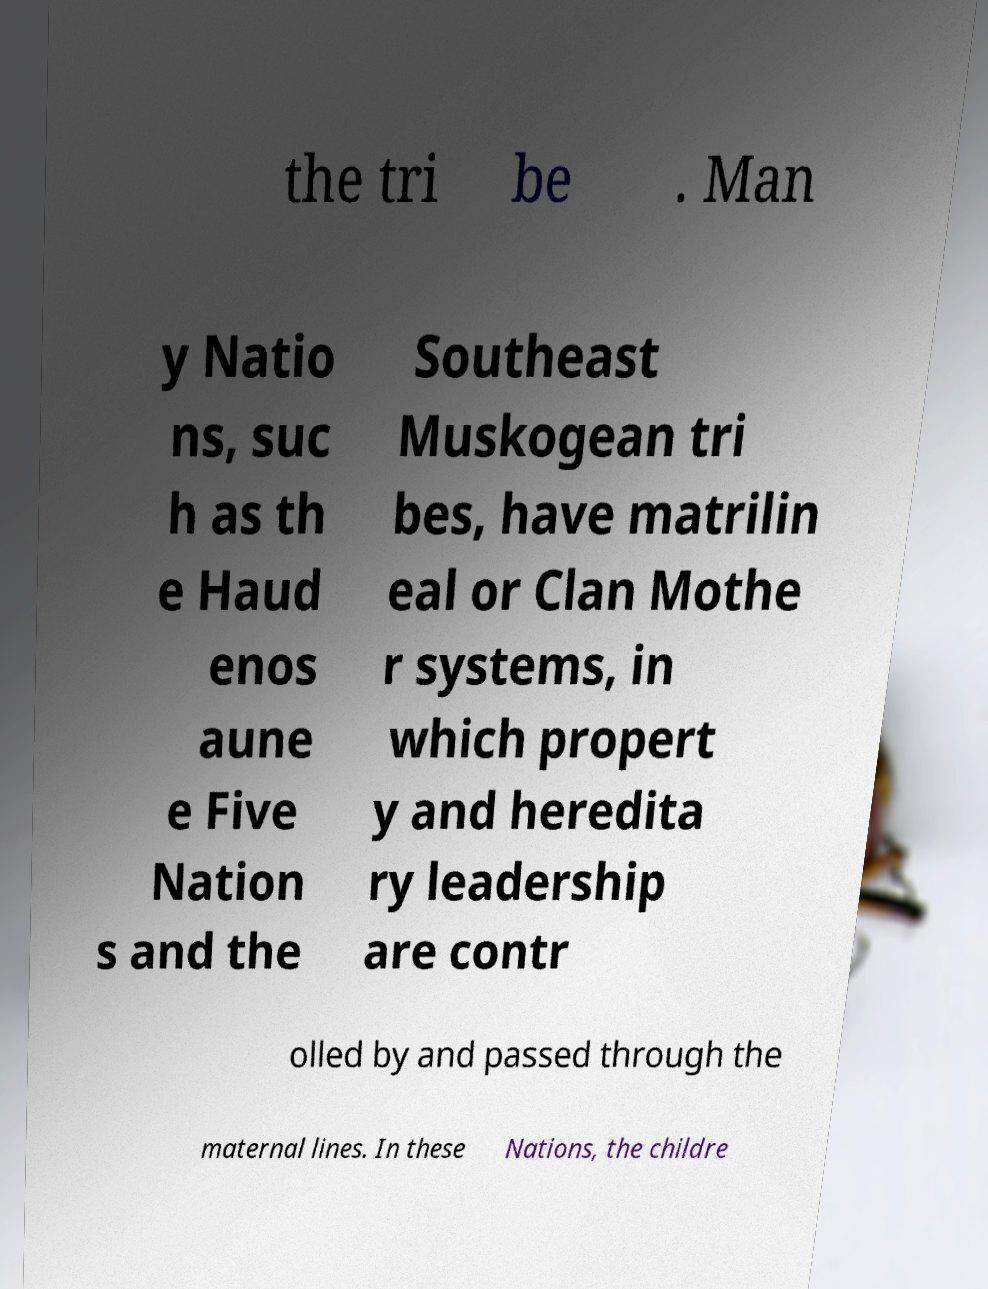Can you accurately transcribe the text from the provided image for me? the tri be . Man y Natio ns, suc h as th e Haud enos aune e Five Nation s and the Southeast Muskogean tri bes, have matrilin eal or Clan Mothe r systems, in which propert y and heredita ry leadership are contr olled by and passed through the maternal lines. In these Nations, the childre 